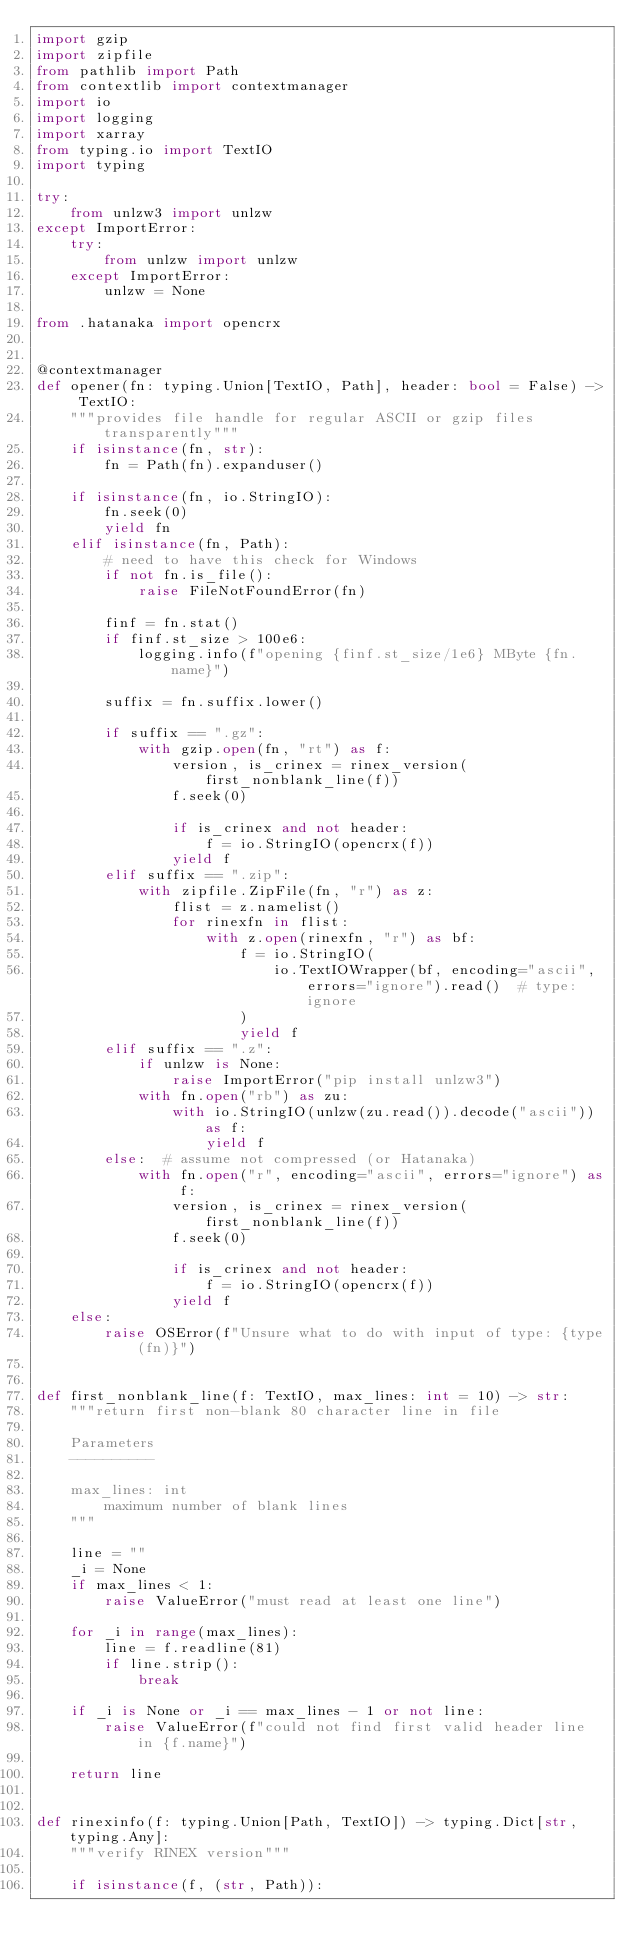<code> <loc_0><loc_0><loc_500><loc_500><_Python_>import gzip
import zipfile
from pathlib import Path
from contextlib import contextmanager
import io
import logging
import xarray
from typing.io import TextIO
import typing

try:
    from unlzw3 import unlzw
except ImportError:
    try:
        from unlzw import unlzw
    except ImportError:
        unlzw = None

from .hatanaka import opencrx


@contextmanager
def opener(fn: typing.Union[TextIO, Path], header: bool = False) -> TextIO:
    """provides file handle for regular ASCII or gzip files transparently"""
    if isinstance(fn, str):
        fn = Path(fn).expanduser()

    if isinstance(fn, io.StringIO):
        fn.seek(0)
        yield fn
    elif isinstance(fn, Path):
        # need to have this check for Windows
        if not fn.is_file():
            raise FileNotFoundError(fn)

        finf = fn.stat()
        if finf.st_size > 100e6:
            logging.info(f"opening {finf.st_size/1e6} MByte {fn.name}")

        suffix = fn.suffix.lower()

        if suffix == ".gz":
            with gzip.open(fn, "rt") as f:
                version, is_crinex = rinex_version(first_nonblank_line(f))
                f.seek(0)

                if is_crinex and not header:
                    f = io.StringIO(opencrx(f))
                yield f
        elif suffix == ".zip":
            with zipfile.ZipFile(fn, "r") as z:
                flist = z.namelist()
                for rinexfn in flist:
                    with z.open(rinexfn, "r") as bf:
                        f = io.StringIO(
                            io.TextIOWrapper(bf, encoding="ascii", errors="ignore").read()  # type: ignore
                        )
                        yield f
        elif suffix == ".z":
            if unlzw is None:
                raise ImportError("pip install unlzw3")
            with fn.open("rb") as zu:
                with io.StringIO(unlzw(zu.read()).decode("ascii")) as f:
                    yield f
        else:  # assume not compressed (or Hatanaka)
            with fn.open("r", encoding="ascii", errors="ignore") as f:
                version, is_crinex = rinex_version(first_nonblank_line(f))
                f.seek(0)

                if is_crinex and not header:
                    f = io.StringIO(opencrx(f))
                yield f
    else:
        raise OSError(f"Unsure what to do with input of type: {type(fn)}")


def first_nonblank_line(f: TextIO, max_lines: int = 10) -> str:
    """return first non-blank 80 character line in file

    Parameters
    ----------

    max_lines: int
        maximum number of blank lines
    """

    line = ""
    _i = None
    if max_lines < 1:
        raise ValueError("must read at least one line")

    for _i in range(max_lines):
        line = f.readline(81)
        if line.strip():
            break

    if _i is None or _i == max_lines - 1 or not line:
        raise ValueError(f"could not find first valid header line in {f.name}")

    return line


def rinexinfo(f: typing.Union[Path, TextIO]) -> typing.Dict[str, typing.Any]:
    """verify RINEX version"""

    if isinstance(f, (str, Path)):</code> 